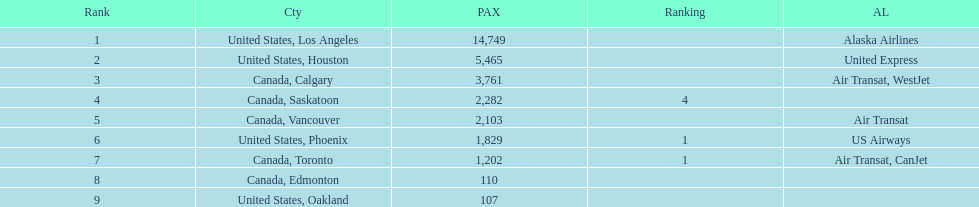Was los angeles or houston the busiest international route at manzanillo international airport in 2013? Los Angeles. 